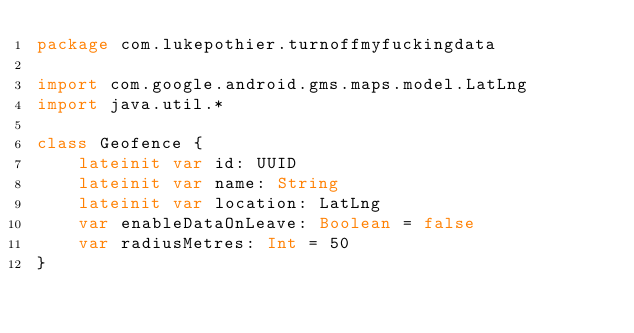<code> <loc_0><loc_0><loc_500><loc_500><_Kotlin_>package com.lukepothier.turnoffmyfuckingdata

import com.google.android.gms.maps.model.LatLng
import java.util.*

class Geofence {
    lateinit var id: UUID
    lateinit var name: String
    lateinit var location: LatLng
    var enableDataOnLeave: Boolean = false
    var radiusMetres: Int = 50
}
</code> 